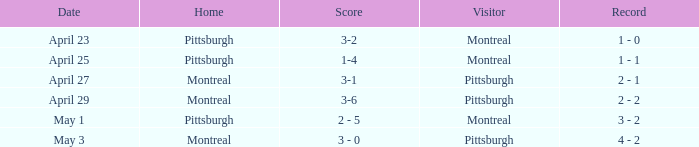When did montreal visit and achieve a 1-4 score? April 25. 